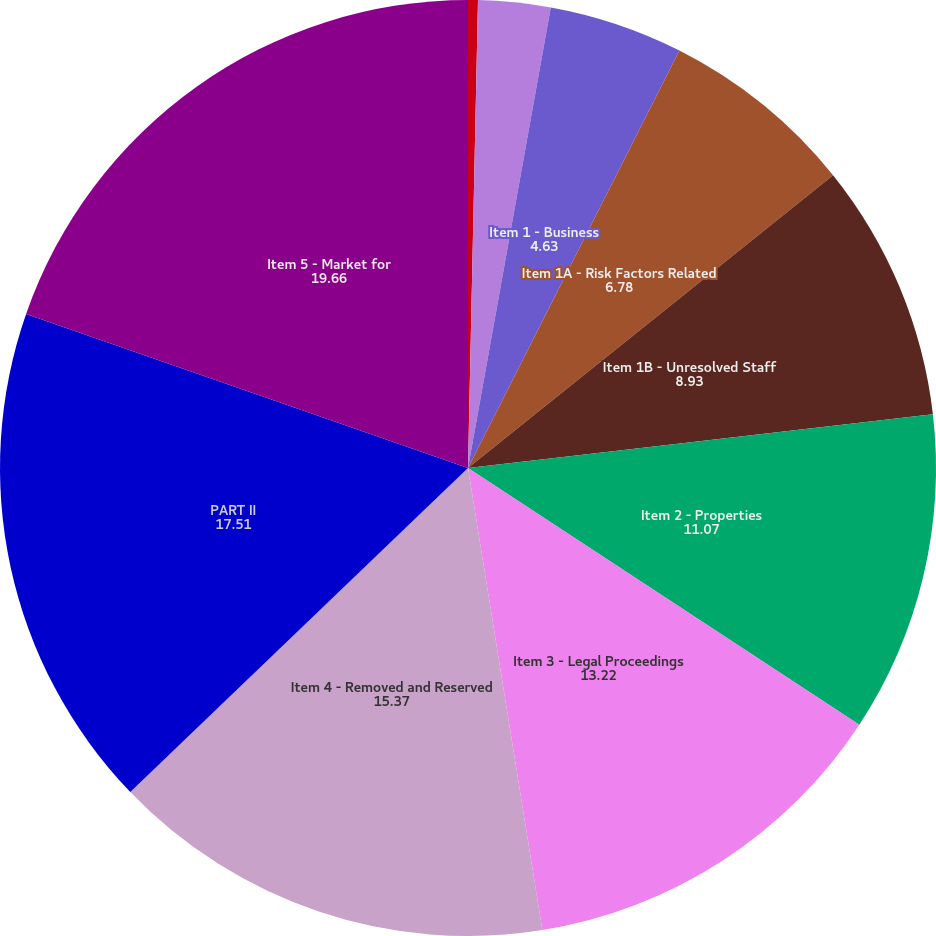<chart> <loc_0><loc_0><loc_500><loc_500><pie_chart><fcel>GLOSSARY OF TERMS<fcel>PART I<fcel>Item 1 - Business<fcel>Item 1A - Risk Factors Related<fcel>Item 1B - Unresolved Staff<fcel>Item 2 - Properties<fcel>Item 3 - Legal Proceedings<fcel>Item 4 - Removed and Reserved<fcel>PART II<fcel>Item 5 - Market for<nl><fcel>0.34%<fcel>2.49%<fcel>4.63%<fcel>6.78%<fcel>8.93%<fcel>11.07%<fcel>13.22%<fcel>15.37%<fcel>17.51%<fcel>19.66%<nl></chart> 